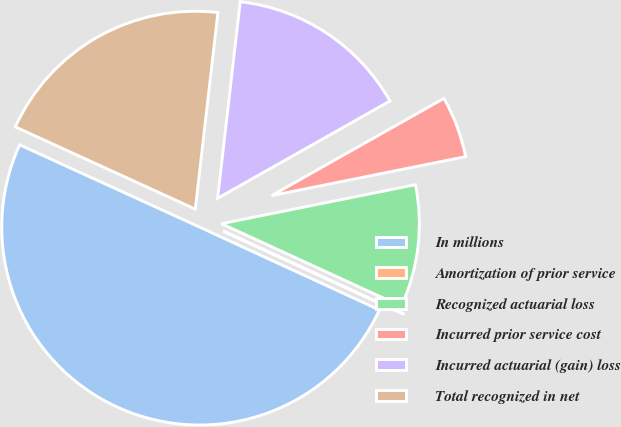Convert chart to OTSL. <chart><loc_0><loc_0><loc_500><loc_500><pie_chart><fcel>In millions<fcel>Amortization of prior service<fcel>Recognized actuarial loss<fcel>Incurred prior service cost<fcel>Incurred actuarial (gain) loss<fcel>Total recognized in net<nl><fcel>49.95%<fcel>0.02%<fcel>10.01%<fcel>5.02%<fcel>15.0%<fcel>20.0%<nl></chart> 